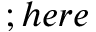Convert formula to latex. <formula><loc_0><loc_0><loc_500><loc_500>; h e r e</formula> 